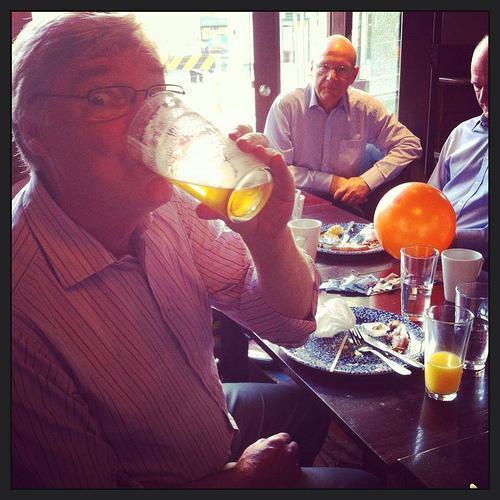How many people are in the picture?
Give a very brief answer. 3. 